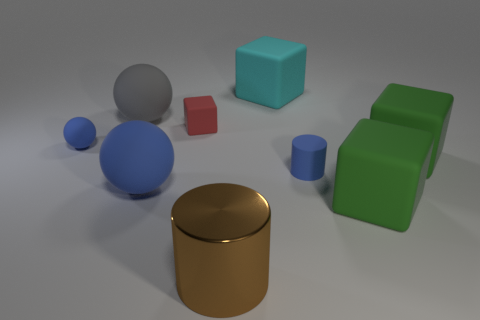Add 1 small brown spheres. How many objects exist? 10 Subtract all blocks. How many objects are left? 5 Subtract 1 blue cylinders. How many objects are left? 8 Subtract all big purple cubes. Subtract all blue rubber things. How many objects are left? 6 Add 6 large cyan matte cubes. How many large cyan matte cubes are left? 7 Add 1 large green rubber cubes. How many large green rubber cubes exist? 3 